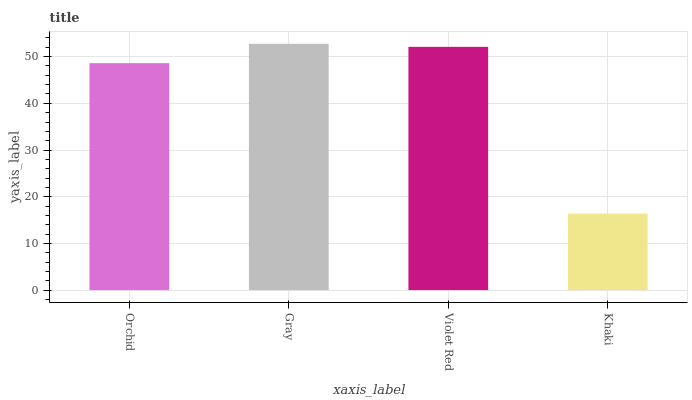Is Khaki the minimum?
Answer yes or no. Yes. Is Gray the maximum?
Answer yes or no. Yes. Is Violet Red the minimum?
Answer yes or no. No. Is Violet Red the maximum?
Answer yes or no. No. Is Gray greater than Violet Red?
Answer yes or no. Yes. Is Violet Red less than Gray?
Answer yes or no. Yes. Is Violet Red greater than Gray?
Answer yes or no. No. Is Gray less than Violet Red?
Answer yes or no. No. Is Violet Red the high median?
Answer yes or no. Yes. Is Orchid the low median?
Answer yes or no. Yes. Is Gray the high median?
Answer yes or no. No. Is Khaki the low median?
Answer yes or no. No. 